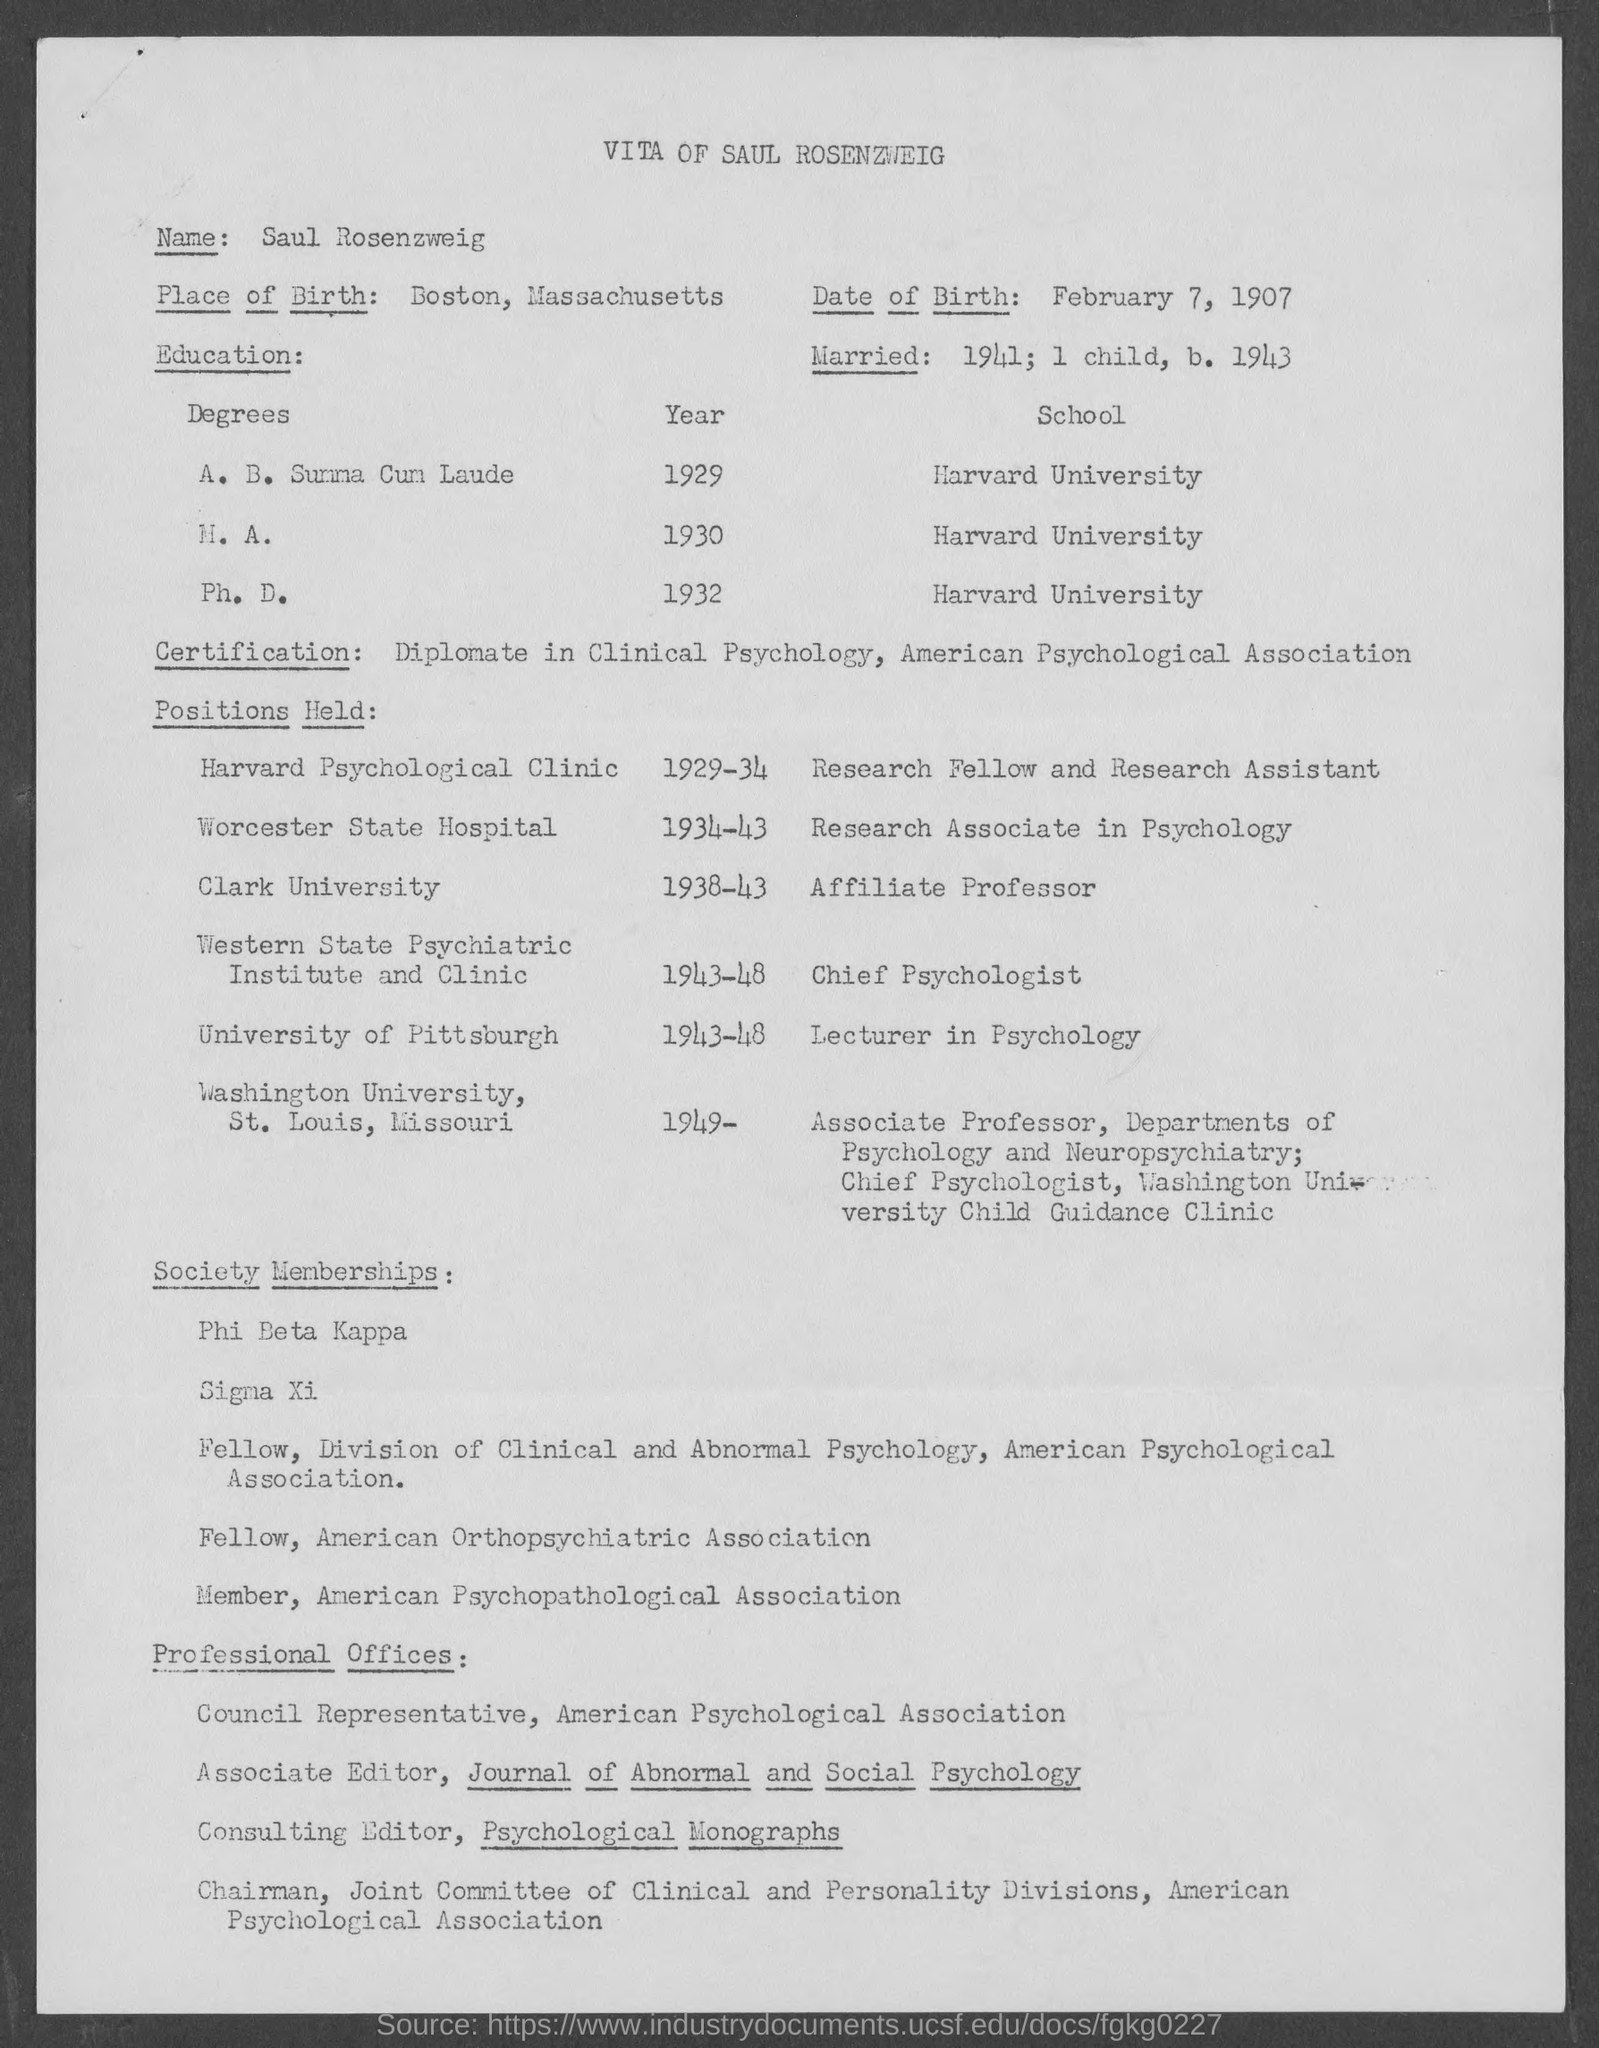Was he affiliated with any professional societies or hold any notable professional offices? He was indeed highly engaged with several professional societies and held esteemed positions. He was a member of Phi Beta Kappa, Sigma Xi, and was a fellow of multiple associations, namely the Division of Clinical and Abnormal Psychology, the American Orthopsychiatric Association, and the American Psychopathological Association. Additionally, he served as a Council Representative for the American Psychological Association among other significant roles. 